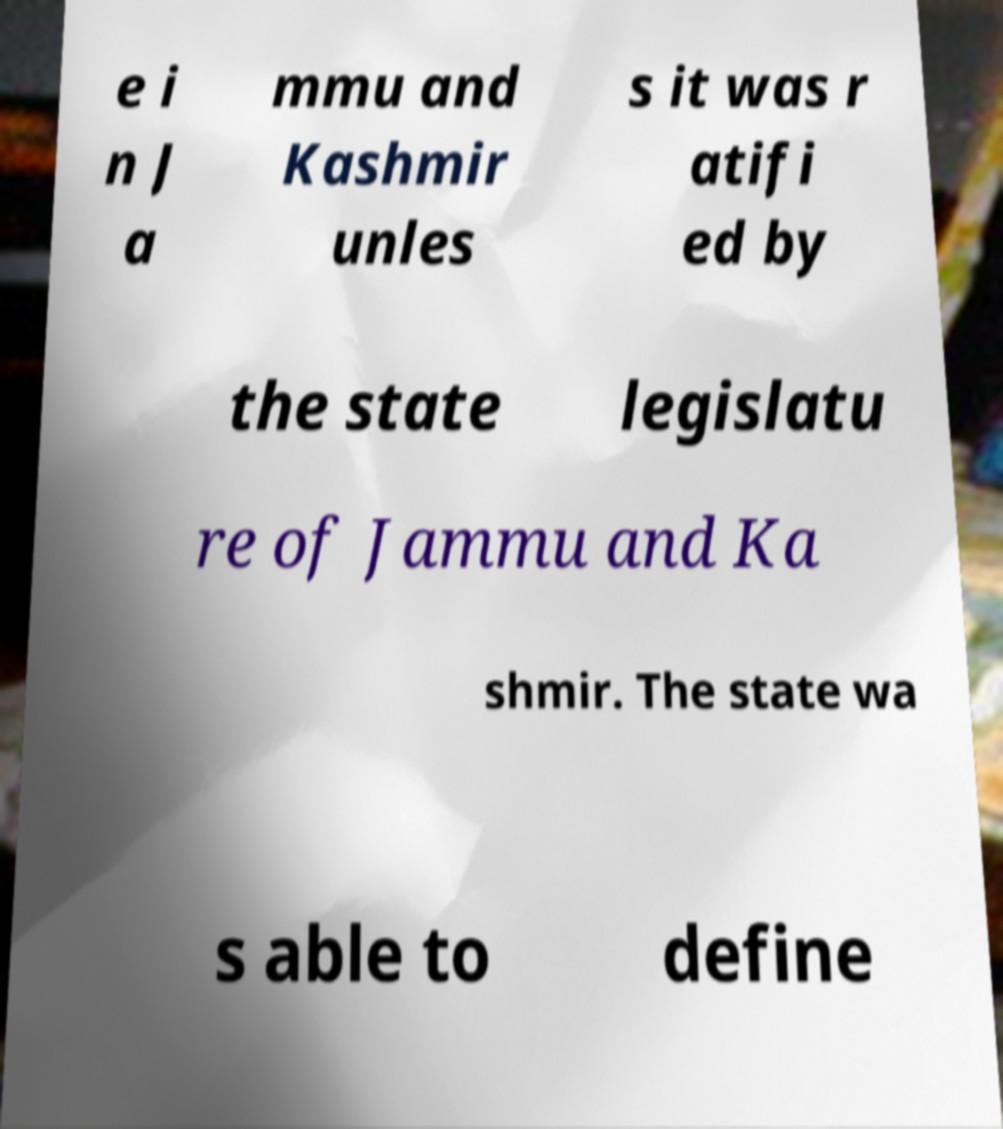There's text embedded in this image that I need extracted. Can you transcribe it verbatim? e i n J a mmu and Kashmir unles s it was r atifi ed by the state legislatu re of Jammu and Ka shmir. The state wa s able to define 